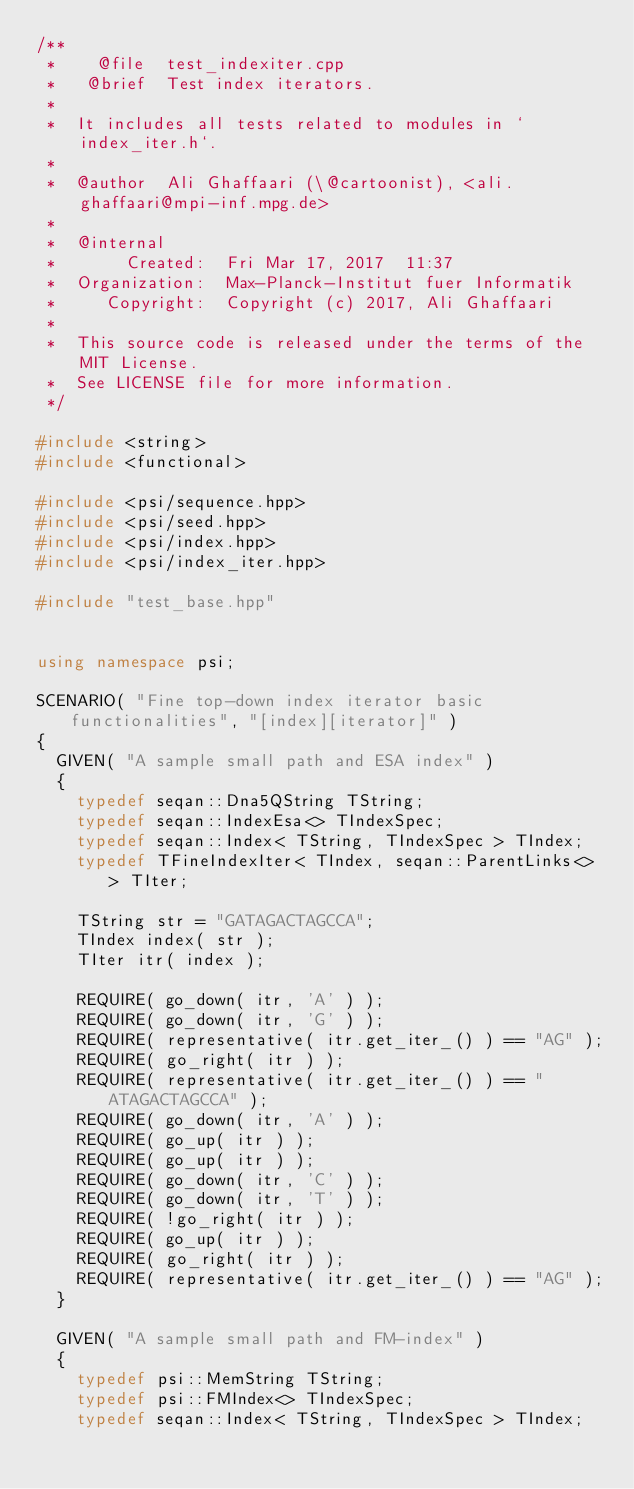<code> <loc_0><loc_0><loc_500><loc_500><_C++_>/**
 *    @file  test_indexiter.cpp
 *   @brief  Test index iterators.
 *
 *  It includes all tests related to modules in `index_iter.h`.
 *
 *  @author  Ali Ghaffaari (\@cartoonist), <ali.ghaffaari@mpi-inf.mpg.de>
 *
 *  @internal
 *       Created:  Fri Mar 17, 2017  11:37
 *  Organization:  Max-Planck-Institut fuer Informatik
 *     Copyright:  Copyright (c) 2017, Ali Ghaffaari
 *
 *  This source code is released under the terms of the MIT License.
 *  See LICENSE file for more information.
 */

#include <string>
#include <functional>

#include <psi/sequence.hpp>
#include <psi/seed.hpp>
#include <psi/index.hpp>
#include <psi/index_iter.hpp>

#include "test_base.hpp"


using namespace psi;

SCENARIO( "Fine top-down index iterator basic functionalities", "[index][iterator]" )
{
  GIVEN( "A sample small path and ESA index" )
  {
    typedef seqan::Dna5QString TString;
    typedef seqan::IndexEsa<> TIndexSpec;
    typedef seqan::Index< TString, TIndexSpec > TIndex;
    typedef TFineIndexIter< TIndex, seqan::ParentLinks<> > TIter;

    TString str = "GATAGACTAGCCA";
    TIndex index( str );
    TIter itr( index );

    REQUIRE( go_down( itr, 'A' ) );
    REQUIRE( go_down( itr, 'G' ) );
    REQUIRE( representative( itr.get_iter_() ) == "AG" );
    REQUIRE( go_right( itr ) );
    REQUIRE( representative( itr.get_iter_() ) == "ATAGACTAGCCA" );
    REQUIRE( go_down( itr, 'A' ) );
    REQUIRE( go_up( itr ) );
    REQUIRE( go_up( itr ) );
    REQUIRE( go_down( itr, 'C' ) );
    REQUIRE( go_down( itr, 'T' ) );
    REQUIRE( !go_right( itr ) );
    REQUIRE( go_up( itr ) );
    REQUIRE( go_right( itr ) );
    REQUIRE( representative( itr.get_iter_() ) == "AG" );
  }

  GIVEN( "A sample small path and FM-index" )
  {
    typedef psi::MemString TString;
    typedef psi::FMIndex<> TIndexSpec;
    typedef seqan::Index< TString, TIndexSpec > TIndex;</code> 